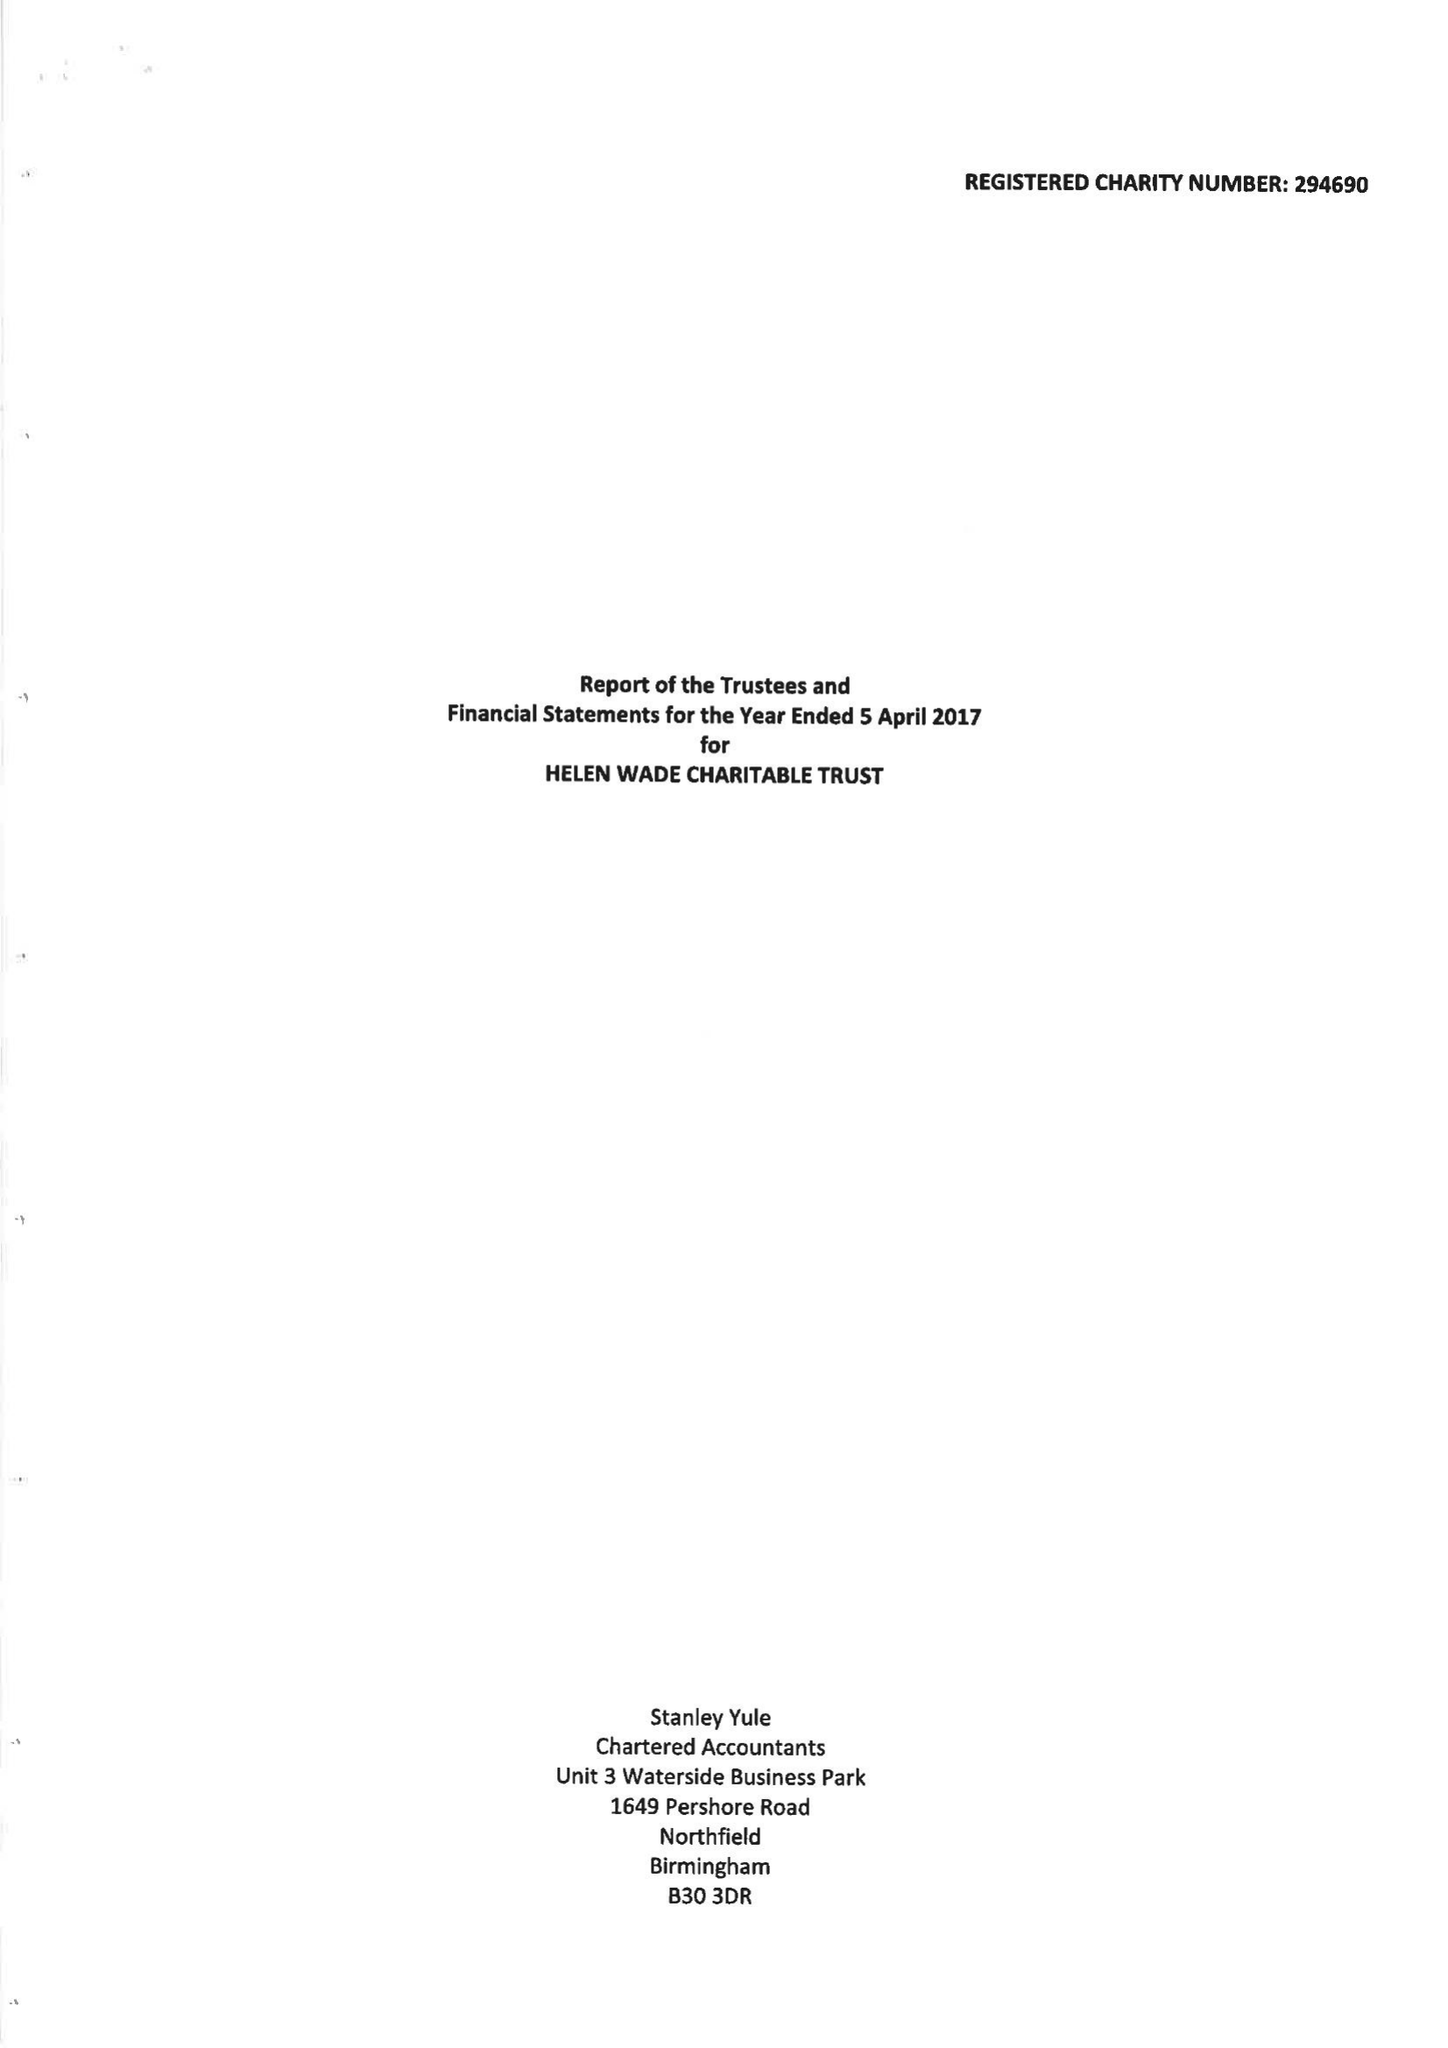What is the value for the charity_name?
Answer the question using a single word or phrase. The Helen Wade Charitable Trust 